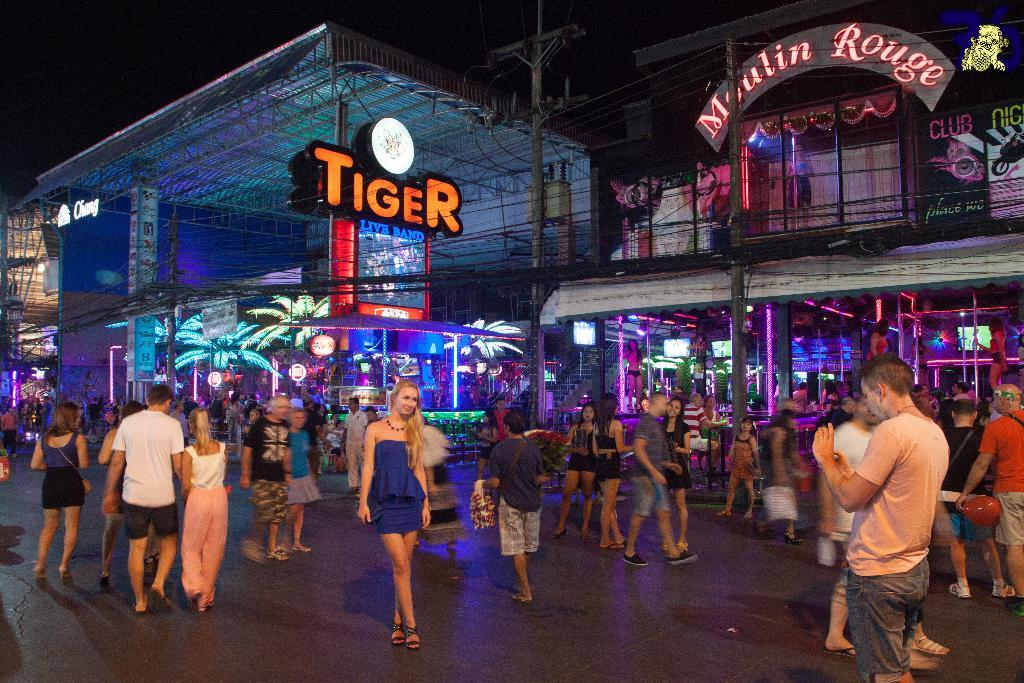How many people are in the image? There is a group of people in the image, but the exact number is not specified. What are the people in the image doing? Some people are standing, while others are walking. What can be seen in the background of the image? In the background, there are poles, cables, lights, hoardings, and buildings. Can you describe the environment in which the people are? The people are in an environment with poles, cables, lights, hoardings, and buildings in the background. What type of arithmetic problem can be seen on the hoardings in the image? There are no arithmetic problems visible on the hoardings in the image. 